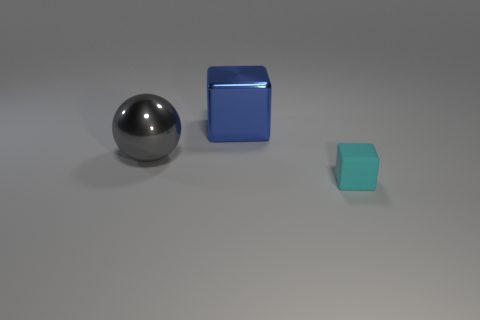Subtract 1 cubes. How many cubes are left? 1 Subtract all cyan cubes. How many cubes are left? 1 Add 3 big brown rubber balls. How many objects exist? 6 Subtract all cubes. How many objects are left? 1 Subtract all purple spheres. How many cyan cubes are left? 1 Subtract all large red rubber blocks. Subtract all large balls. How many objects are left? 2 Add 1 small rubber blocks. How many small rubber blocks are left? 2 Add 3 tiny green shiny cylinders. How many tiny green shiny cylinders exist? 3 Subtract 0 green spheres. How many objects are left? 3 Subtract all purple blocks. Subtract all gray cylinders. How many blocks are left? 2 